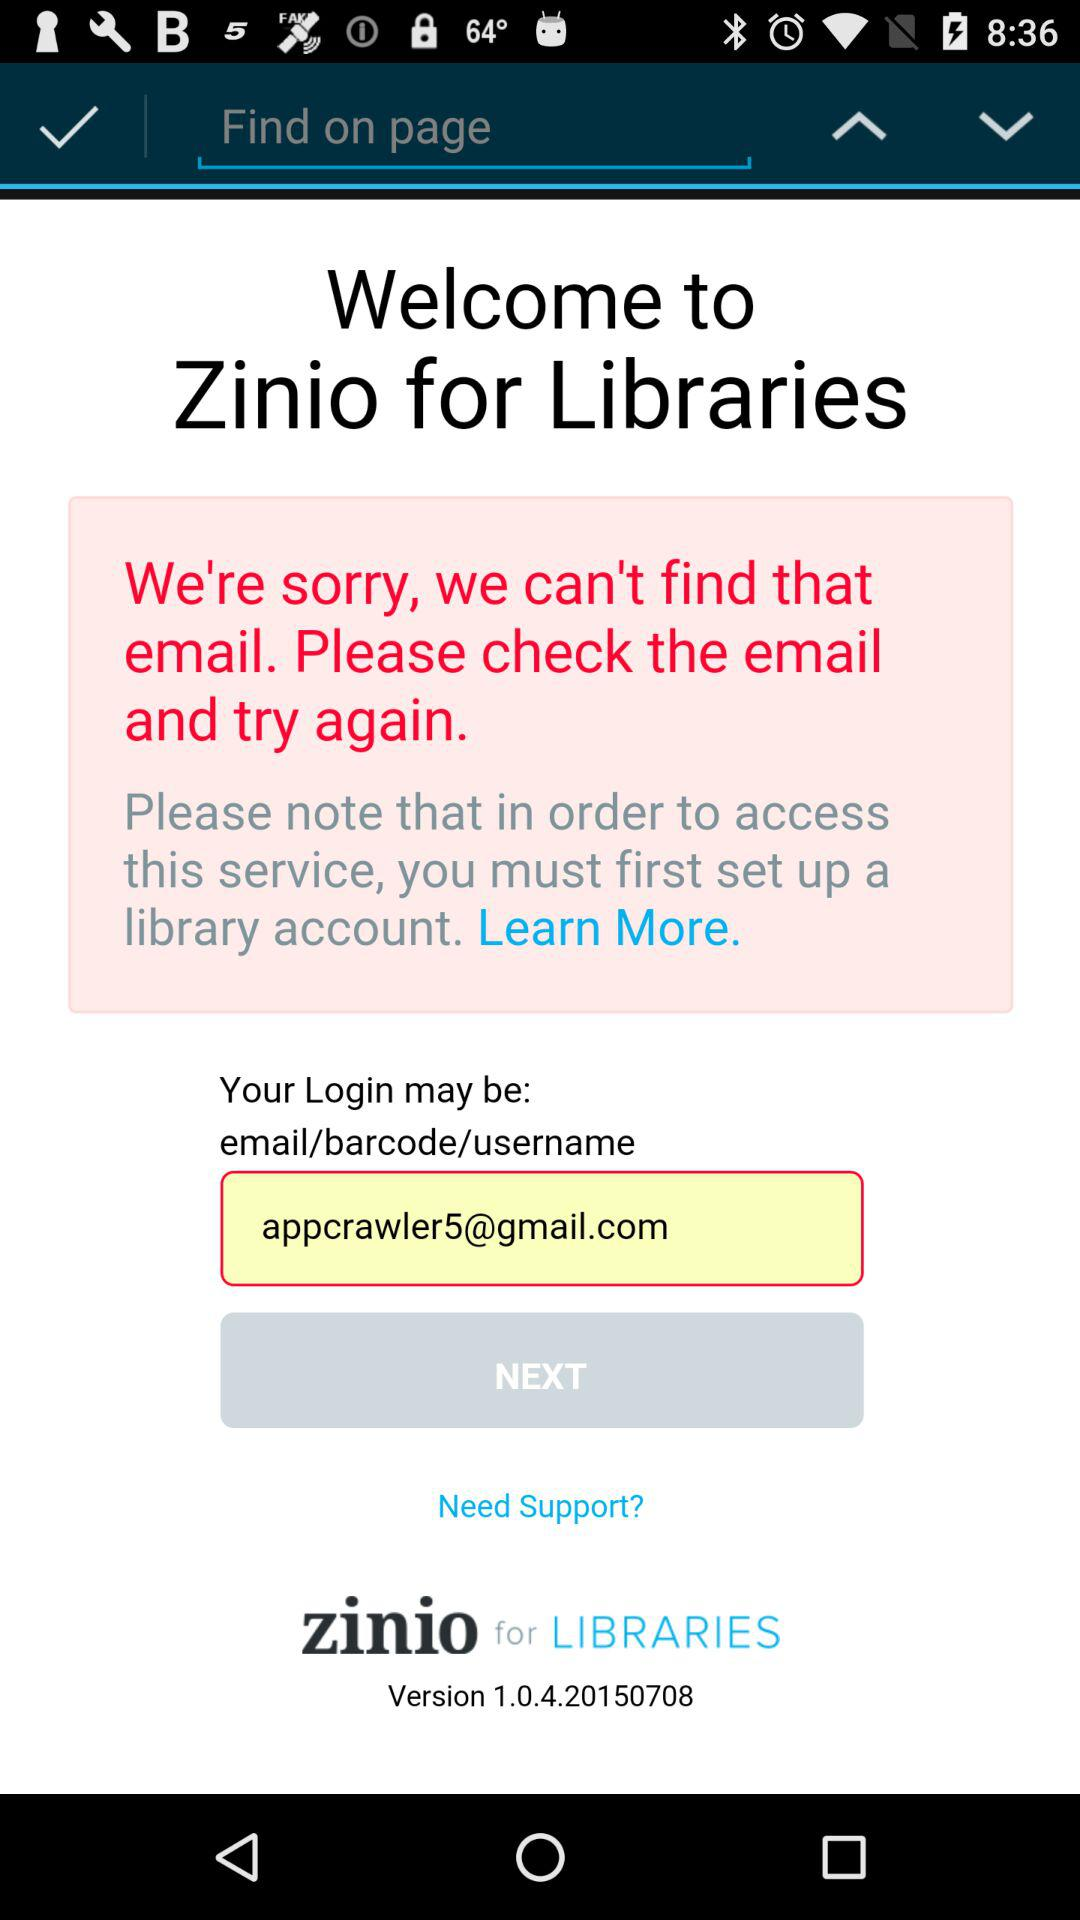What is the email address? The email address is appcrawler5@gmail.com. 